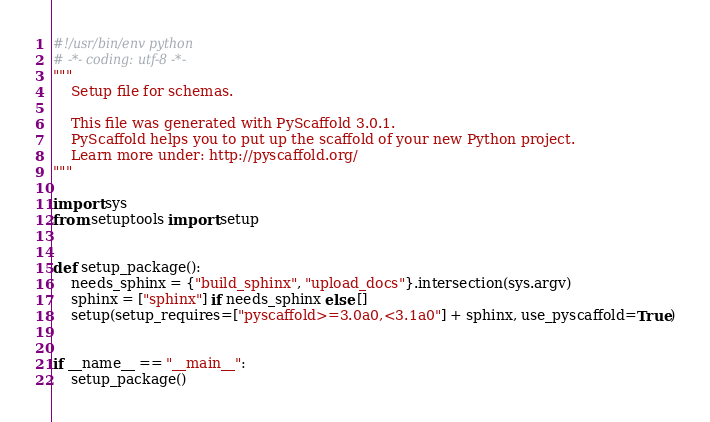Convert code to text. <code><loc_0><loc_0><loc_500><loc_500><_Python_>#!/usr/bin/env python
# -*- coding: utf-8 -*-
"""
    Setup file for schemas.

    This file was generated with PyScaffold 3.0.1.
    PyScaffold helps you to put up the scaffold of your new Python project.
    Learn more under: http://pyscaffold.org/
"""

import sys
from setuptools import setup


def setup_package():
    needs_sphinx = {"build_sphinx", "upload_docs"}.intersection(sys.argv)
    sphinx = ["sphinx"] if needs_sphinx else []
    setup(setup_requires=["pyscaffold>=3.0a0,<3.1a0"] + sphinx, use_pyscaffold=True)


if __name__ == "__main__":
    setup_package()
</code> 